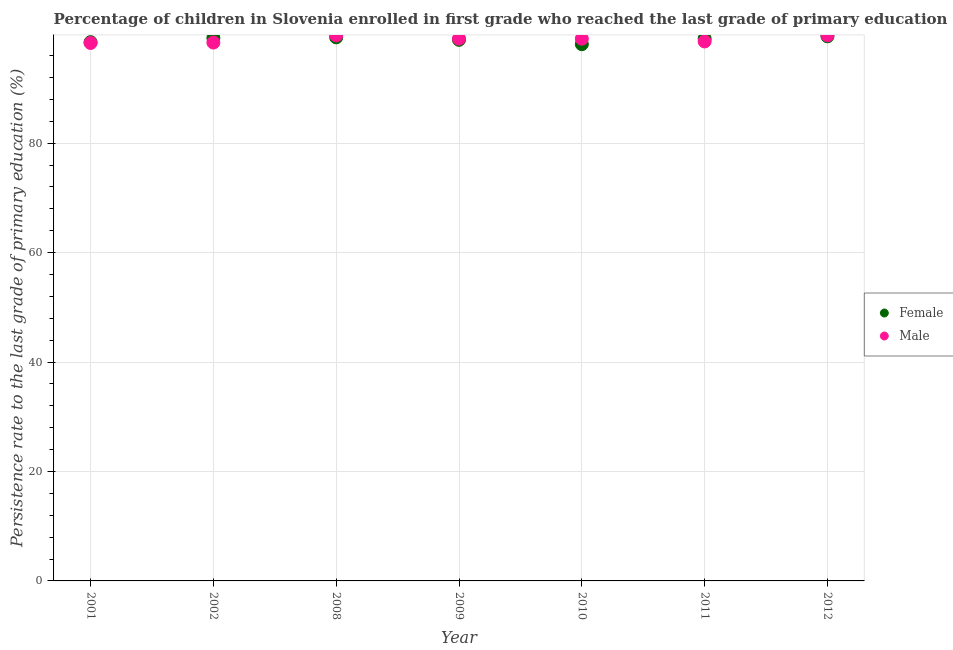How many different coloured dotlines are there?
Offer a very short reply. 2. What is the persistence rate of female students in 2009?
Provide a short and direct response. 98.88. Across all years, what is the maximum persistence rate of male students?
Make the answer very short. 99.7. Across all years, what is the minimum persistence rate of female students?
Your answer should be compact. 98.08. In which year was the persistence rate of female students maximum?
Your answer should be very brief. 2012. In which year was the persistence rate of female students minimum?
Offer a terse response. 2010. What is the total persistence rate of male students in the graph?
Keep it short and to the point. 692.83. What is the difference between the persistence rate of male students in 2002 and that in 2010?
Offer a terse response. -0.7. What is the difference between the persistence rate of male students in 2011 and the persistence rate of female students in 2001?
Your response must be concise. 0.13. What is the average persistence rate of female students per year?
Offer a very short reply. 98.94. In the year 2011, what is the difference between the persistence rate of female students and persistence rate of male students?
Make the answer very short. 0.51. What is the ratio of the persistence rate of male students in 2002 to that in 2012?
Provide a short and direct response. 0.99. Is the persistence rate of female students in 2002 less than that in 2009?
Offer a terse response. No. Is the difference between the persistence rate of male students in 2002 and 2010 greater than the difference between the persistence rate of female students in 2002 and 2010?
Keep it short and to the point. No. What is the difference between the highest and the second highest persistence rate of female students?
Offer a very short reply. 0.2. What is the difference between the highest and the lowest persistence rate of female students?
Offer a very short reply. 1.44. In how many years, is the persistence rate of male students greater than the average persistence rate of male students taken over all years?
Offer a terse response. 4. Does the persistence rate of female students monotonically increase over the years?
Your response must be concise. No. What is the difference between two consecutive major ticks on the Y-axis?
Ensure brevity in your answer.  20. Does the graph contain any zero values?
Give a very brief answer. No. Does the graph contain grids?
Offer a terse response. Yes. How are the legend labels stacked?
Your answer should be very brief. Vertical. What is the title of the graph?
Give a very brief answer. Percentage of children in Slovenia enrolled in first grade who reached the last grade of primary education. Does "Not attending school" appear as one of the legend labels in the graph?
Keep it short and to the point. No. What is the label or title of the Y-axis?
Offer a terse response. Persistence rate to the last grade of primary education (%). What is the Persistence rate to the last grade of primary education (%) in Female in 2001?
Make the answer very short. 98.45. What is the Persistence rate to the last grade of primary education (%) in Male in 2001?
Your answer should be compact. 98.3. What is the Persistence rate to the last grade of primary education (%) in Female in 2002?
Offer a very short reply. 99.23. What is the Persistence rate to the last grade of primary education (%) in Male in 2002?
Keep it short and to the point. 98.38. What is the Persistence rate to the last grade of primary education (%) in Female in 2008?
Give a very brief answer. 99.32. What is the Persistence rate to the last grade of primary education (%) in Male in 2008?
Your answer should be very brief. 99.69. What is the Persistence rate to the last grade of primary education (%) in Female in 2009?
Your answer should be compact. 98.88. What is the Persistence rate to the last grade of primary education (%) in Male in 2009?
Keep it short and to the point. 99.1. What is the Persistence rate to the last grade of primary education (%) in Female in 2010?
Provide a succinct answer. 98.08. What is the Persistence rate to the last grade of primary education (%) in Male in 2010?
Provide a short and direct response. 99.08. What is the Persistence rate to the last grade of primary education (%) of Female in 2011?
Offer a terse response. 99.09. What is the Persistence rate to the last grade of primary education (%) in Male in 2011?
Provide a short and direct response. 98.58. What is the Persistence rate to the last grade of primary education (%) of Female in 2012?
Offer a terse response. 99.52. What is the Persistence rate to the last grade of primary education (%) of Male in 2012?
Make the answer very short. 99.7. Across all years, what is the maximum Persistence rate to the last grade of primary education (%) in Female?
Provide a short and direct response. 99.52. Across all years, what is the maximum Persistence rate to the last grade of primary education (%) of Male?
Ensure brevity in your answer.  99.7. Across all years, what is the minimum Persistence rate to the last grade of primary education (%) in Female?
Offer a terse response. 98.08. Across all years, what is the minimum Persistence rate to the last grade of primary education (%) in Male?
Give a very brief answer. 98.3. What is the total Persistence rate to the last grade of primary education (%) in Female in the graph?
Make the answer very short. 692.57. What is the total Persistence rate to the last grade of primary education (%) of Male in the graph?
Offer a very short reply. 692.83. What is the difference between the Persistence rate to the last grade of primary education (%) of Female in 2001 and that in 2002?
Give a very brief answer. -0.77. What is the difference between the Persistence rate to the last grade of primary education (%) in Male in 2001 and that in 2002?
Your answer should be very brief. -0.08. What is the difference between the Persistence rate to the last grade of primary education (%) of Female in 2001 and that in 2008?
Provide a succinct answer. -0.87. What is the difference between the Persistence rate to the last grade of primary education (%) in Male in 2001 and that in 2008?
Offer a terse response. -1.39. What is the difference between the Persistence rate to the last grade of primary education (%) of Female in 2001 and that in 2009?
Your answer should be very brief. -0.43. What is the difference between the Persistence rate to the last grade of primary education (%) of Male in 2001 and that in 2009?
Keep it short and to the point. -0.79. What is the difference between the Persistence rate to the last grade of primary education (%) in Female in 2001 and that in 2010?
Your answer should be compact. 0.37. What is the difference between the Persistence rate to the last grade of primary education (%) of Male in 2001 and that in 2010?
Offer a terse response. -0.78. What is the difference between the Persistence rate to the last grade of primary education (%) in Female in 2001 and that in 2011?
Offer a terse response. -0.64. What is the difference between the Persistence rate to the last grade of primary education (%) of Male in 2001 and that in 2011?
Provide a short and direct response. -0.28. What is the difference between the Persistence rate to the last grade of primary education (%) in Female in 2001 and that in 2012?
Your response must be concise. -1.07. What is the difference between the Persistence rate to the last grade of primary education (%) of Male in 2001 and that in 2012?
Provide a succinct answer. -1.4. What is the difference between the Persistence rate to the last grade of primary education (%) in Female in 2002 and that in 2008?
Offer a very short reply. -0.1. What is the difference between the Persistence rate to the last grade of primary education (%) of Male in 2002 and that in 2008?
Offer a terse response. -1.31. What is the difference between the Persistence rate to the last grade of primary education (%) of Female in 2002 and that in 2009?
Your answer should be compact. 0.35. What is the difference between the Persistence rate to the last grade of primary education (%) in Male in 2002 and that in 2009?
Offer a terse response. -0.72. What is the difference between the Persistence rate to the last grade of primary education (%) in Female in 2002 and that in 2010?
Offer a terse response. 1.15. What is the difference between the Persistence rate to the last grade of primary education (%) of Male in 2002 and that in 2010?
Keep it short and to the point. -0.7. What is the difference between the Persistence rate to the last grade of primary education (%) in Female in 2002 and that in 2011?
Provide a short and direct response. 0.14. What is the difference between the Persistence rate to the last grade of primary education (%) in Male in 2002 and that in 2011?
Offer a very short reply. -0.2. What is the difference between the Persistence rate to the last grade of primary education (%) of Female in 2002 and that in 2012?
Provide a short and direct response. -0.29. What is the difference between the Persistence rate to the last grade of primary education (%) of Male in 2002 and that in 2012?
Offer a terse response. -1.32. What is the difference between the Persistence rate to the last grade of primary education (%) in Female in 2008 and that in 2009?
Offer a terse response. 0.45. What is the difference between the Persistence rate to the last grade of primary education (%) of Male in 2008 and that in 2009?
Offer a very short reply. 0.6. What is the difference between the Persistence rate to the last grade of primary education (%) of Female in 2008 and that in 2010?
Ensure brevity in your answer.  1.25. What is the difference between the Persistence rate to the last grade of primary education (%) of Male in 2008 and that in 2010?
Ensure brevity in your answer.  0.61. What is the difference between the Persistence rate to the last grade of primary education (%) in Female in 2008 and that in 2011?
Offer a very short reply. 0.24. What is the difference between the Persistence rate to the last grade of primary education (%) in Male in 2008 and that in 2011?
Offer a terse response. 1.12. What is the difference between the Persistence rate to the last grade of primary education (%) in Female in 2008 and that in 2012?
Keep it short and to the point. -0.2. What is the difference between the Persistence rate to the last grade of primary education (%) of Male in 2008 and that in 2012?
Your response must be concise. -0.01. What is the difference between the Persistence rate to the last grade of primary education (%) of Female in 2009 and that in 2010?
Offer a terse response. 0.8. What is the difference between the Persistence rate to the last grade of primary education (%) in Male in 2009 and that in 2010?
Offer a terse response. 0.01. What is the difference between the Persistence rate to the last grade of primary education (%) of Female in 2009 and that in 2011?
Your response must be concise. -0.21. What is the difference between the Persistence rate to the last grade of primary education (%) of Male in 2009 and that in 2011?
Offer a very short reply. 0.52. What is the difference between the Persistence rate to the last grade of primary education (%) in Female in 2009 and that in 2012?
Provide a short and direct response. -0.64. What is the difference between the Persistence rate to the last grade of primary education (%) in Male in 2009 and that in 2012?
Make the answer very short. -0.61. What is the difference between the Persistence rate to the last grade of primary education (%) in Female in 2010 and that in 2011?
Keep it short and to the point. -1.01. What is the difference between the Persistence rate to the last grade of primary education (%) of Male in 2010 and that in 2011?
Provide a succinct answer. 0.5. What is the difference between the Persistence rate to the last grade of primary education (%) of Female in 2010 and that in 2012?
Provide a succinct answer. -1.44. What is the difference between the Persistence rate to the last grade of primary education (%) of Male in 2010 and that in 2012?
Keep it short and to the point. -0.62. What is the difference between the Persistence rate to the last grade of primary education (%) in Female in 2011 and that in 2012?
Make the answer very short. -0.43. What is the difference between the Persistence rate to the last grade of primary education (%) in Male in 2011 and that in 2012?
Your answer should be compact. -1.12. What is the difference between the Persistence rate to the last grade of primary education (%) in Female in 2001 and the Persistence rate to the last grade of primary education (%) in Male in 2002?
Keep it short and to the point. 0.07. What is the difference between the Persistence rate to the last grade of primary education (%) in Female in 2001 and the Persistence rate to the last grade of primary education (%) in Male in 2008?
Offer a terse response. -1.24. What is the difference between the Persistence rate to the last grade of primary education (%) in Female in 2001 and the Persistence rate to the last grade of primary education (%) in Male in 2009?
Give a very brief answer. -0.64. What is the difference between the Persistence rate to the last grade of primary education (%) in Female in 2001 and the Persistence rate to the last grade of primary education (%) in Male in 2010?
Your answer should be very brief. -0.63. What is the difference between the Persistence rate to the last grade of primary education (%) of Female in 2001 and the Persistence rate to the last grade of primary education (%) of Male in 2011?
Your answer should be compact. -0.13. What is the difference between the Persistence rate to the last grade of primary education (%) in Female in 2001 and the Persistence rate to the last grade of primary education (%) in Male in 2012?
Provide a succinct answer. -1.25. What is the difference between the Persistence rate to the last grade of primary education (%) in Female in 2002 and the Persistence rate to the last grade of primary education (%) in Male in 2008?
Make the answer very short. -0.47. What is the difference between the Persistence rate to the last grade of primary education (%) in Female in 2002 and the Persistence rate to the last grade of primary education (%) in Male in 2009?
Make the answer very short. 0.13. What is the difference between the Persistence rate to the last grade of primary education (%) of Female in 2002 and the Persistence rate to the last grade of primary education (%) of Male in 2010?
Your answer should be compact. 0.15. What is the difference between the Persistence rate to the last grade of primary education (%) in Female in 2002 and the Persistence rate to the last grade of primary education (%) in Male in 2011?
Provide a short and direct response. 0.65. What is the difference between the Persistence rate to the last grade of primary education (%) of Female in 2002 and the Persistence rate to the last grade of primary education (%) of Male in 2012?
Make the answer very short. -0.47. What is the difference between the Persistence rate to the last grade of primary education (%) of Female in 2008 and the Persistence rate to the last grade of primary education (%) of Male in 2009?
Provide a succinct answer. 0.23. What is the difference between the Persistence rate to the last grade of primary education (%) in Female in 2008 and the Persistence rate to the last grade of primary education (%) in Male in 2010?
Give a very brief answer. 0.24. What is the difference between the Persistence rate to the last grade of primary education (%) of Female in 2008 and the Persistence rate to the last grade of primary education (%) of Male in 2011?
Provide a short and direct response. 0.75. What is the difference between the Persistence rate to the last grade of primary education (%) of Female in 2008 and the Persistence rate to the last grade of primary education (%) of Male in 2012?
Your answer should be compact. -0.38. What is the difference between the Persistence rate to the last grade of primary education (%) of Female in 2009 and the Persistence rate to the last grade of primary education (%) of Male in 2010?
Make the answer very short. -0.2. What is the difference between the Persistence rate to the last grade of primary education (%) of Female in 2009 and the Persistence rate to the last grade of primary education (%) of Male in 2011?
Provide a succinct answer. 0.3. What is the difference between the Persistence rate to the last grade of primary education (%) of Female in 2009 and the Persistence rate to the last grade of primary education (%) of Male in 2012?
Your answer should be very brief. -0.82. What is the difference between the Persistence rate to the last grade of primary education (%) of Female in 2010 and the Persistence rate to the last grade of primary education (%) of Male in 2011?
Provide a succinct answer. -0.5. What is the difference between the Persistence rate to the last grade of primary education (%) in Female in 2010 and the Persistence rate to the last grade of primary education (%) in Male in 2012?
Provide a succinct answer. -1.62. What is the difference between the Persistence rate to the last grade of primary education (%) of Female in 2011 and the Persistence rate to the last grade of primary education (%) of Male in 2012?
Provide a succinct answer. -0.61. What is the average Persistence rate to the last grade of primary education (%) of Female per year?
Your answer should be compact. 98.94. What is the average Persistence rate to the last grade of primary education (%) in Male per year?
Provide a short and direct response. 98.98. In the year 2001, what is the difference between the Persistence rate to the last grade of primary education (%) in Female and Persistence rate to the last grade of primary education (%) in Male?
Offer a terse response. 0.15. In the year 2002, what is the difference between the Persistence rate to the last grade of primary education (%) of Female and Persistence rate to the last grade of primary education (%) of Male?
Make the answer very short. 0.85. In the year 2008, what is the difference between the Persistence rate to the last grade of primary education (%) of Female and Persistence rate to the last grade of primary education (%) of Male?
Make the answer very short. -0.37. In the year 2009, what is the difference between the Persistence rate to the last grade of primary education (%) in Female and Persistence rate to the last grade of primary education (%) in Male?
Keep it short and to the point. -0.22. In the year 2010, what is the difference between the Persistence rate to the last grade of primary education (%) of Female and Persistence rate to the last grade of primary education (%) of Male?
Provide a short and direct response. -1. In the year 2011, what is the difference between the Persistence rate to the last grade of primary education (%) in Female and Persistence rate to the last grade of primary education (%) in Male?
Offer a terse response. 0.51. In the year 2012, what is the difference between the Persistence rate to the last grade of primary education (%) in Female and Persistence rate to the last grade of primary education (%) in Male?
Ensure brevity in your answer.  -0.18. What is the ratio of the Persistence rate to the last grade of primary education (%) of Female in 2001 to that in 2002?
Offer a very short reply. 0.99. What is the ratio of the Persistence rate to the last grade of primary education (%) of Male in 2001 to that in 2002?
Give a very brief answer. 1. What is the ratio of the Persistence rate to the last grade of primary education (%) of Male in 2001 to that in 2008?
Your response must be concise. 0.99. What is the ratio of the Persistence rate to the last grade of primary education (%) in Male in 2001 to that in 2010?
Your response must be concise. 0.99. What is the ratio of the Persistence rate to the last grade of primary education (%) of Female in 2001 to that in 2011?
Your answer should be compact. 0.99. What is the ratio of the Persistence rate to the last grade of primary education (%) in Female in 2001 to that in 2012?
Offer a terse response. 0.99. What is the ratio of the Persistence rate to the last grade of primary education (%) in Female in 2002 to that in 2008?
Your answer should be compact. 1. What is the ratio of the Persistence rate to the last grade of primary education (%) of Male in 2002 to that in 2008?
Your answer should be very brief. 0.99. What is the ratio of the Persistence rate to the last grade of primary education (%) of Female in 2002 to that in 2009?
Your answer should be very brief. 1. What is the ratio of the Persistence rate to the last grade of primary education (%) in Male in 2002 to that in 2009?
Give a very brief answer. 0.99. What is the ratio of the Persistence rate to the last grade of primary education (%) in Female in 2002 to that in 2010?
Provide a succinct answer. 1.01. What is the ratio of the Persistence rate to the last grade of primary education (%) of Female in 2002 to that in 2011?
Offer a very short reply. 1. What is the ratio of the Persistence rate to the last grade of primary education (%) of Male in 2002 to that in 2011?
Your response must be concise. 1. What is the ratio of the Persistence rate to the last grade of primary education (%) in Female in 2008 to that in 2009?
Make the answer very short. 1. What is the ratio of the Persistence rate to the last grade of primary education (%) in Female in 2008 to that in 2010?
Make the answer very short. 1.01. What is the ratio of the Persistence rate to the last grade of primary education (%) of Male in 2008 to that in 2011?
Your response must be concise. 1.01. What is the ratio of the Persistence rate to the last grade of primary education (%) of Female in 2008 to that in 2012?
Provide a short and direct response. 1. What is the ratio of the Persistence rate to the last grade of primary education (%) in Male in 2008 to that in 2012?
Offer a terse response. 1. What is the ratio of the Persistence rate to the last grade of primary education (%) in Female in 2009 to that in 2010?
Keep it short and to the point. 1.01. What is the ratio of the Persistence rate to the last grade of primary education (%) in Female in 2009 to that in 2012?
Your answer should be very brief. 0.99. What is the ratio of the Persistence rate to the last grade of primary education (%) in Female in 2010 to that in 2012?
Offer a very short reply. 0.99. What is the ratio of the Persistence rate to the last grade of primary education (%) of Male in 2011 to that in 2012?
Your response must be concise. 0.99. What is the difference between the highest and the second highest Persistence rate to the last grade of primary education (%) of Female?
Give a very brief answer. 0.2. What is the difference between the highest and the second highest Persistence rate to the last grade of primary education (%) of Male?
Ensure brevity in your answer.  0.01. What is the difference between the highest and the lowest Persistence rate to the last grade of primary education (%) of Female?
Provide a short and direct response. 1.44. What is the difference between the highest and the lowest Persistence rate to the last grade of primary education (%) in Male?
Provide a succinct answer. 1.4. 